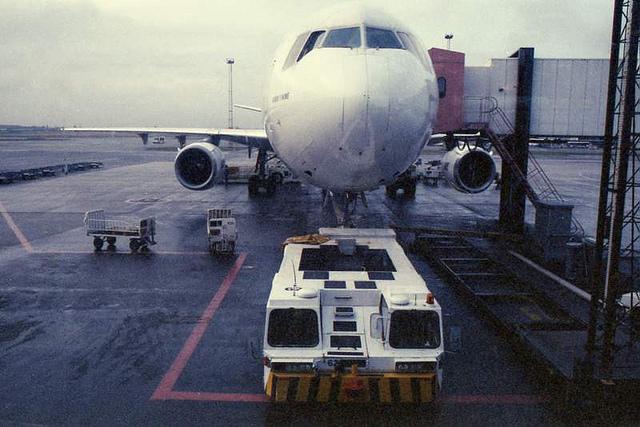Is this plane for military use?
Keep it brief. No. Is this plane in use?
Be succinct. No. Are there any people?
Concise answer only. No. Is the plane refueling?
Be succinct. No. What is the color of the plane?
Be succinct. White. What color is the sky?
Quick response, please. Gray. Is it safe to load the passengers now?
Give a very brief answer. Yes. Where is this?
Short answer required. Airport. What color is the line?
Answer briefly. Red. Is this a propeller plane?
Be succinct. No. 